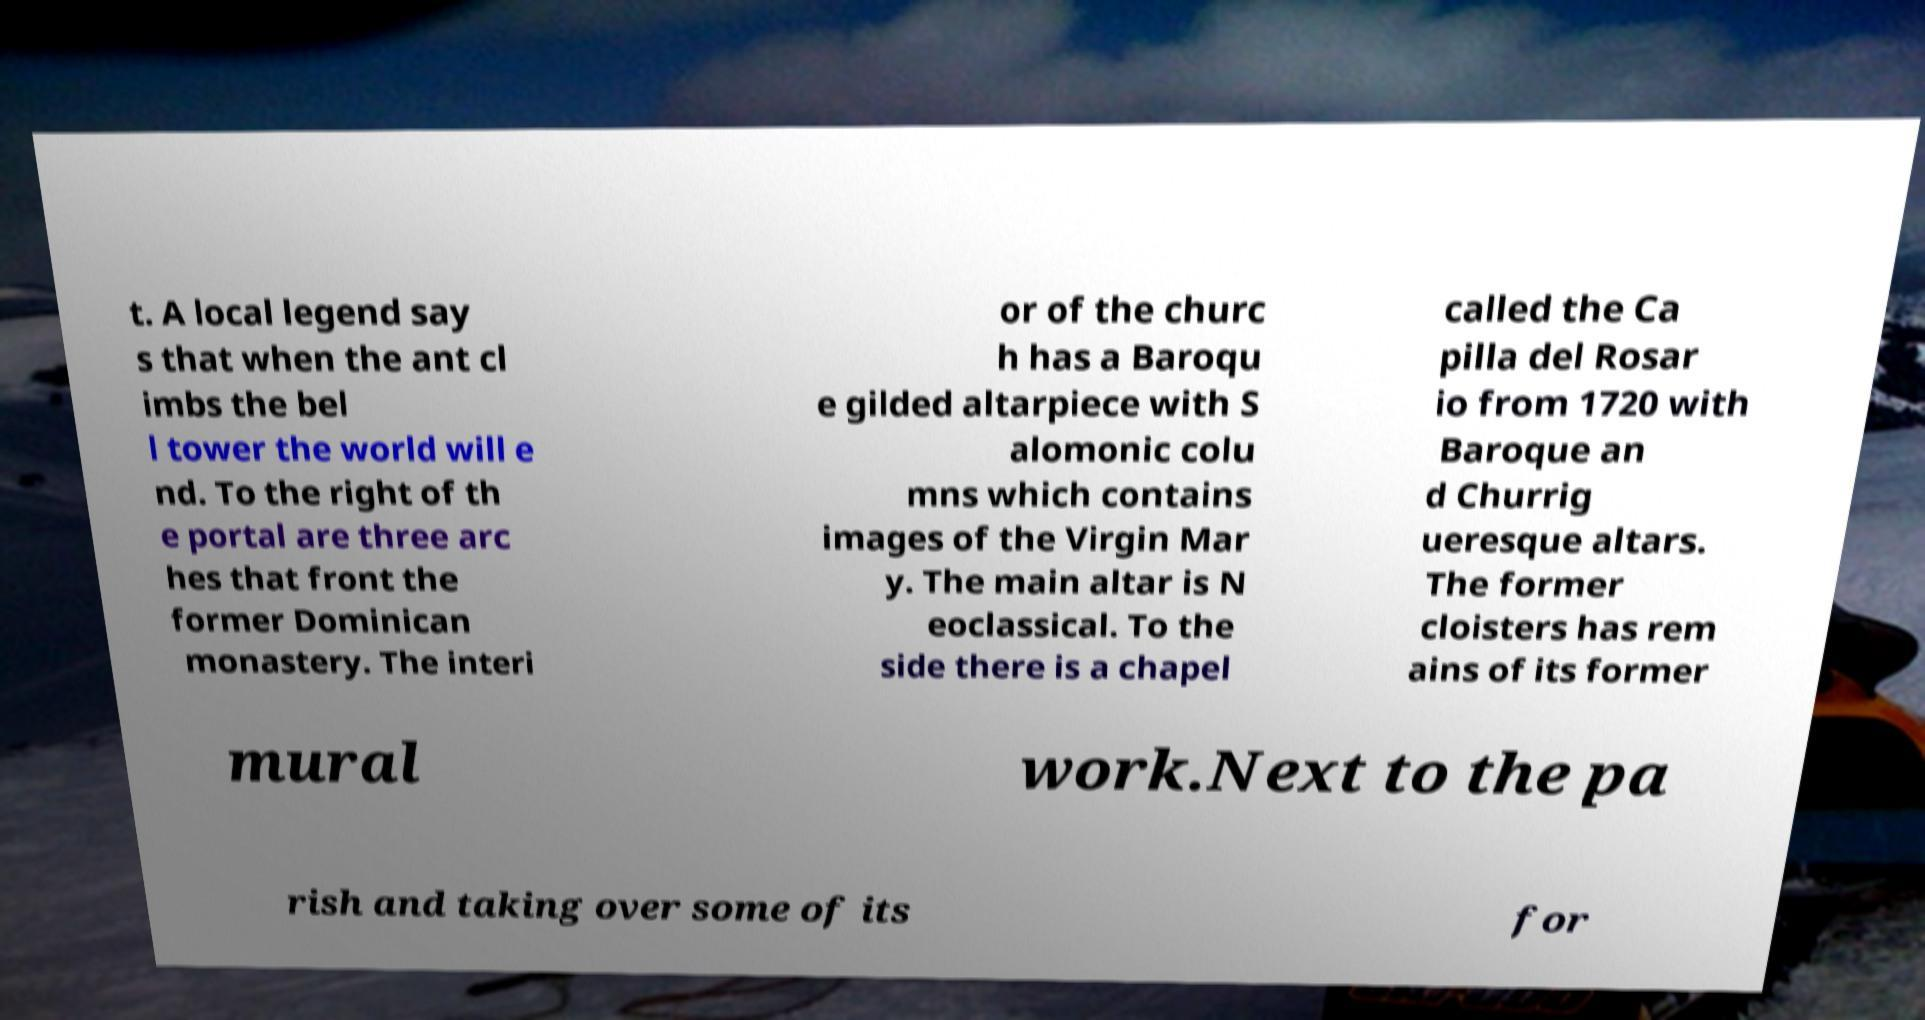Please identify and transcribe the text found in this image. t. A local legend say s that when the ant cl imbs the bel l tower the world will e nd. To the right of th e portal are three arc hes that front the former Dominican monastery. The interi or of the churc h has a Baroqu e gilded altarpiece with S alomonic colu mns which contains images of the Virgin Mar y. The main altar is N eoclassical. To the side there is a chapel called the Ca pilla del Rosar io from 1720 with Baroque an d Churrig ueresque altars. The former cloisters has rem ains of its former mural work.Next to the pa rish and taking over some of its for 